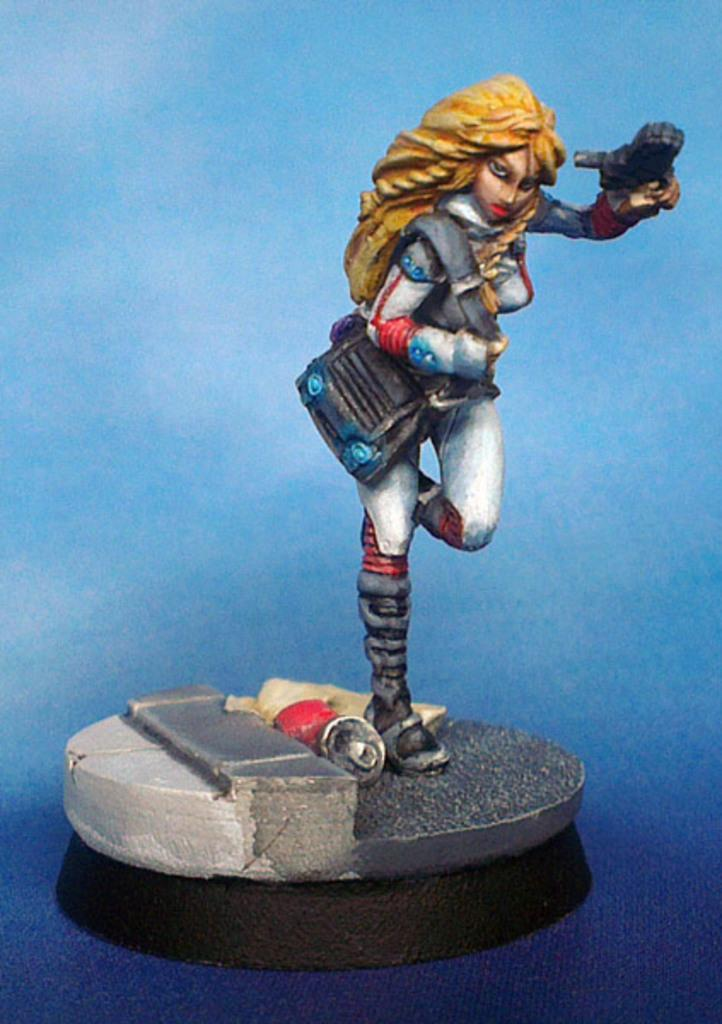What is the main subject of the image? There is a woman toy in the image. Are there any other objects in the image besides the woman toy? Yes, there are other objects in the image. What color is the background of the image? The background of the image is blue in color. How many stamps are on the woman toy in the image? There are no stamps present on the woman toy in the image. 